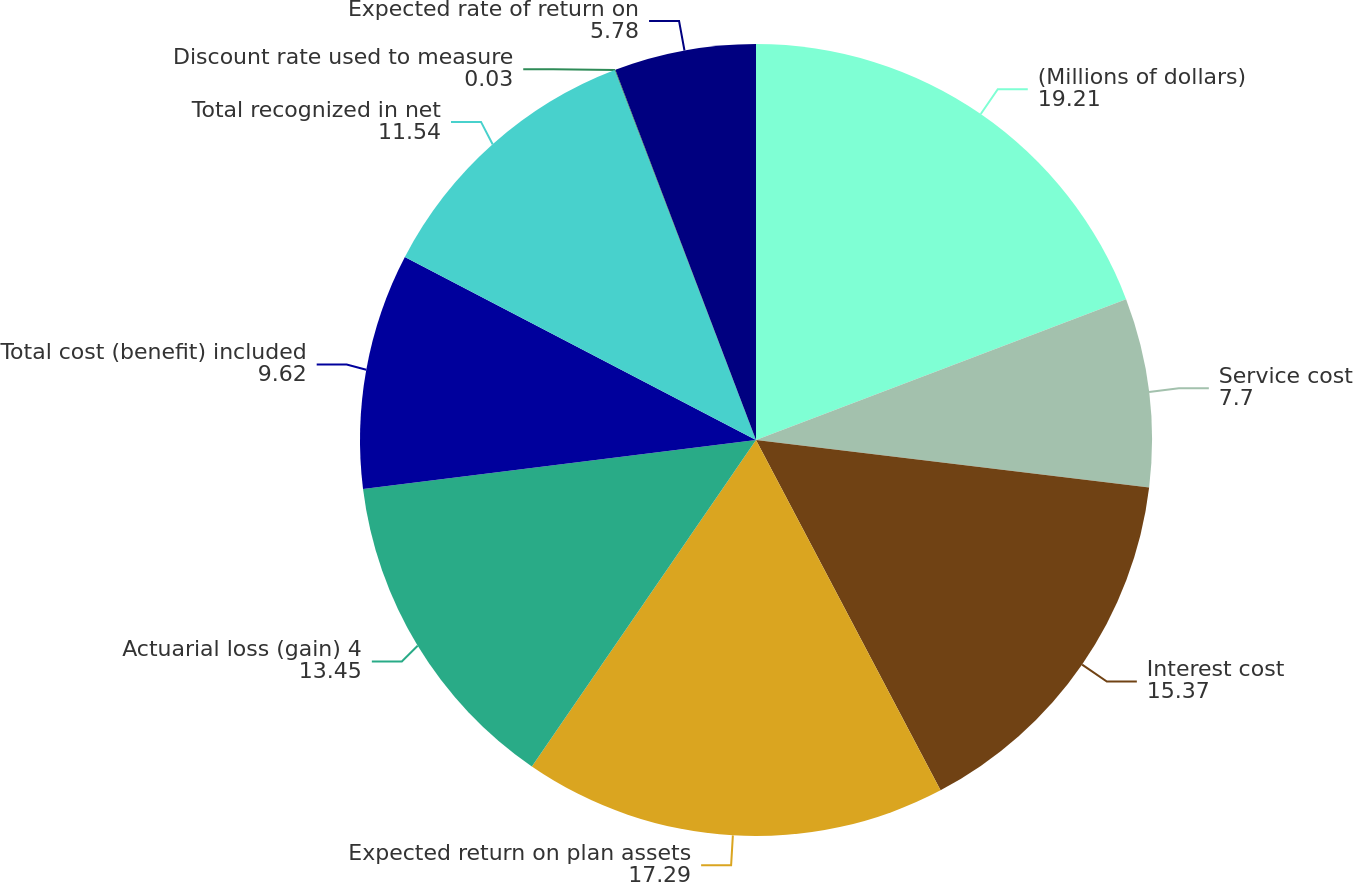Convert chart. <chart><loc_0><loc_0><loc_500><loc_500><pie_chart><fcel>(Millions of dollars)<fcel>Service cost<fcel>Interest cost<fcel>Expected return on plan assets<fcel>Actuarial loss (gain) 4<fcel>Total cost (benefit) included<fcel>Total recognized in net<fcel>Discount rate used to measure<fcel>Expected rate of return on<nl><fcel>19.21%<fcel>7.7%<fcel>15.37%<fcel>17.29%<fcel>13.45%<fcel>9.62%<fcel>11.54%<fcel>0.03%<fcel>5.78%<nl></chart> 